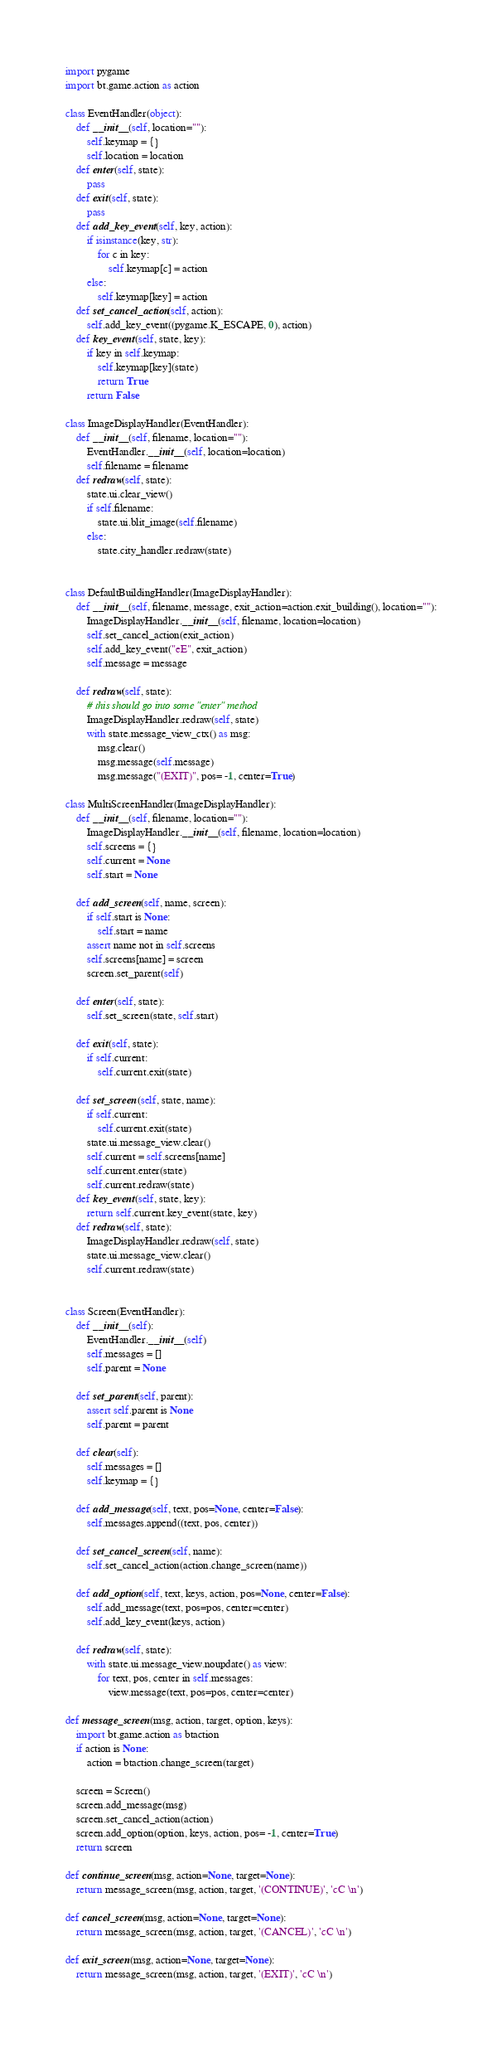<code> <loc_0><loc_0><loc_500><loc_500><_Python_>import pygame
import bt.game.action as action

class EventHandler(object):
    def __init__(self, location=""):
        self.keymap = {}
        self.location = location
    def enter(self, state):
        pass
    def exit(self, state):
        pass
    def add_key_event(self, key, action):
        if isinstance(key, str):
            for c in key:
                self.keymap[c] = action
        else:
            self.keymap[key] = action
    def set_cancel_action(self, action):
        self.add_key_event((pygame.K_ESCAPE, 0), action)
    def key_event(self, state, key):
        if key in self.keymap:
            self.keymap[key](state)
            return True
        return False

class ImageDisplayHandler(EventHandler):
    def __init__(self, filename, location=""):
        EventHandler.__init__(self, location=location)
        self.filename = filename
    def redraw(self, state):
        state.ui.clear_view()
        if self.filename:
            state.ui.blit_image(self.filename)
        else:
            state.city_handler.redraw(state)


class DefaultBuildingHandler(ImageDisplayHandler):
    def __init__(self, filename, message, exit_action=action.exit_building(), location=""):
        ImageDisplayHandler.__init__(self, filename, location=location)
        self.set_cancel_action(exit_action)
        self.add_key_event("eE", exit_action)
        self.message = message

    def redraw(self, state):
        # this should go into some "enter" method
        ImageDisplayHandler.redraw(self, state)
        with state.message_view_ctx() as msg:
            msg.clear()
            msg.message(self.message)
            msg.message("(EXIT)", pos= -1, center=True)

class MultiScreenHandler(ImageDisplayHandler):
    def __init__(self, filename, location=""):
        ImageDisplayHandler.__init__(self, filename, location=location)
        self.screens = {}
        self.current = None
        self.start = None

    def add_screen(self, name, screen):
        if self.start is None:
            self.start = name
        assert name not in self.screens
        self.screens[name] = screen
        screen.set_parent(self)

    def enter(self, state):
        self.set_screen(state, self.start)

    def exit(self, state):
        if self.current:
            self.current.exit(state)

    def set_screen(self, state, name):
        if self.current:
            self.current.exit(state)
        state.ui.message_view.clear()
        self.current = self.screens[name]
        self.current.enter(state)
        self.current.redraw(state)
    def key_event(self, state, key):
        return self.current.key_event(state, key)
    def redraw(self, state):
        ImageDisplayHandler.redraw(self, state)
        state.ui.message_view.clear()
        self.current.redraw(state)


class Screen(EventHandler):
    def __init__(self):
        EventHandler.__init__(self)
        self.messages = []
        self.parent = None

    def set_parent(self, parent):
        assert self.parent is None
        self.parent = parent

    def clear(self):
        self.messages = []
        self.keymap = {}

    def add_message(self, text, pos=None, center=False):
        self.messages.append((text, pos, center))

    def set_cancel_screen(self, name):
        self.set_cancel_action(action.change_screen(name))

    def add_option(self, text, keys, action, pos=None, center=False):
        self.add_message(text, pos=pos, center=center)
        self.add_key_event(keys, action)

    def redraw(self, state):
        with state.ui.message_view.noupdate() as view:
            for text, pos, center in self.messages:
                view.message(text, pos=pos, center=center)

def message_screen(msg, action, target, option, keys):
    import bt.game.action as btaction
    if action is None:
        action = btaction.change_screen(target)

    screen = Screen()
    screen.add_message(msg)
    screen.set_cancel_action(action)
    screen.add_option(option, keys, action, pos= -1, center=True)
    return screen

def continue_screen(msg, action=None, target=None):
    return message_screen(msg, action, target, '(CONTINUE)', 'cC \n')

def cancel_screen(msg, action=None, target=None):
    return message_screen(msg, action, target, '(CANCEL)', 'cC \n')

def exit_screen(msg, action=None, target=None):
    return message_screen(msg, action, target, '(EXIT)', 'cC \n')

</code> 